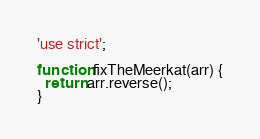Convert code to text. <code><loc_0><loc_0><loc_500><loc_500><_JavaScript_>'use strict';

function fixTheMeerkat(arr) {
  return arr.reverse();
}


</code> 